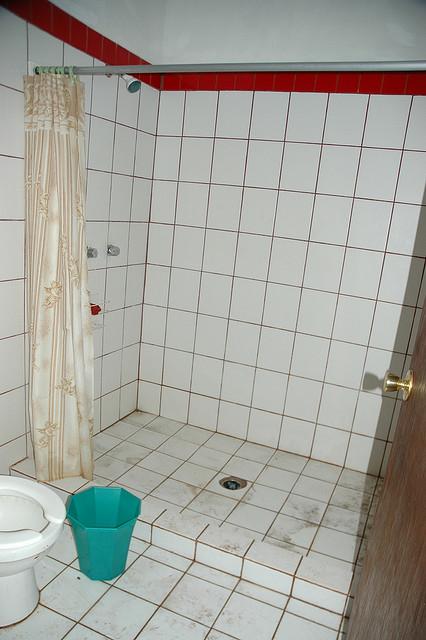Is the floor dirty?
Write a very short answer. Yes. What room of the house is this?
Be succinct. Bathroom. Is someone cleaning the bathroom?
Write a very short answer. No. 